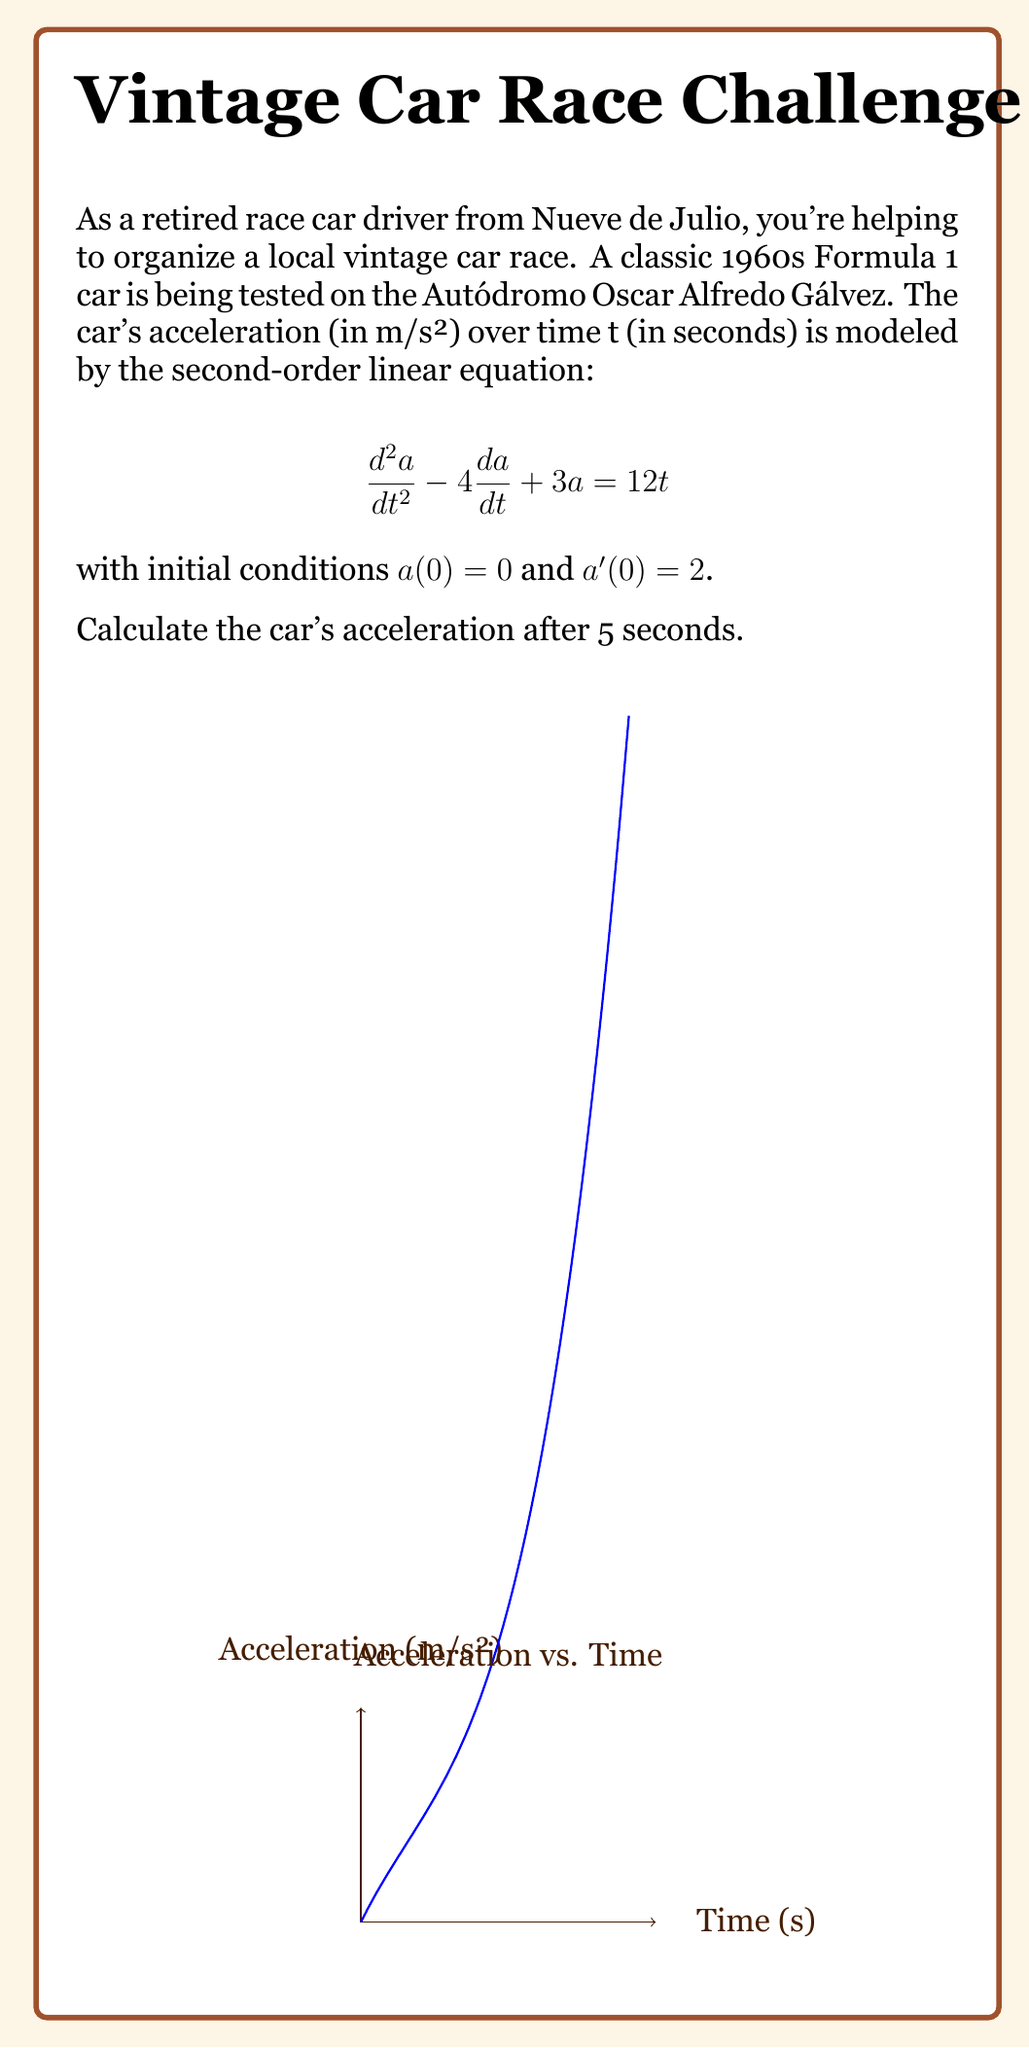Can you solve this math problem? To solve this problem, we need to follow these steps:

1) The general solution for this second-order linear equation is:
   $$a(t) = c_1e^{t} + c_2e^{3t} + 4t - 1$$

2) We need to find $c_1$ and $c_2$ using the initial conditions:

   For $a(0) = 0$:
   $$0 = c_1 + c_2 - 1$$

   For $a'(0) = 2$:
   $$a'(t) = c_1e^t + 3c_2e^{3t} + 4$$
   $$2 = c_1 + 3c_2 + 4$$

3) Solving these equations:
   $c_1 + c_2 = 1$
   $c_1 + 3c_2 = -2$
   
   Subtracting, we get: $-2c_2 = -3$, so $c_2 = \frac{3}{2}$
   Substituting back: $c_1 = 1 - \frac{3}{2} = -\frac{1}{2}$

4) Therefore, the particular solution is:
   $$a(t) = -\frac{1}{2}e^t + \frac{3}{2}e^{3t} + 4t - 1$$

5) To find the acceleration at t = 5:
   $$a(5) = -\frac{1}{2}e^5 + \frac{3}{2}e^{15} + 4(5) - 1$$

6) Calculating this:
   $$a(5) \approx -74.2 + 4,478,554.1 + 20 - 1 = 4,478,498.9$$
Answer: $4,478,498.9$ m/s² 